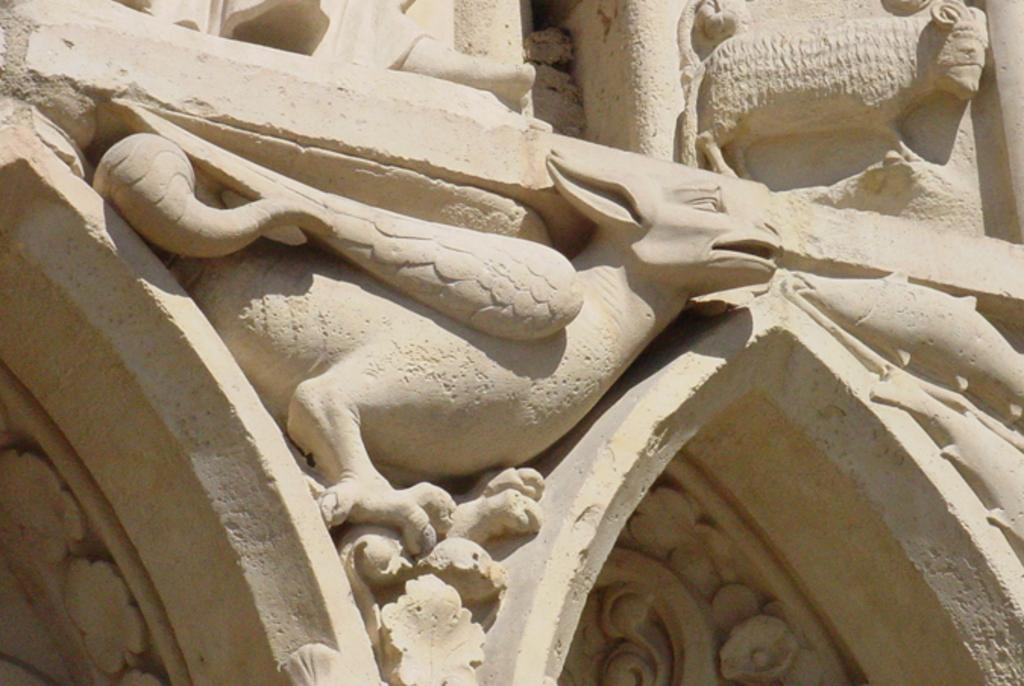What type of artwork can be seen on the wall in the image? There are sculptures on the wall in the image. Can you describe the sculptures in more detail? Unfortunately, the image does not provide enough detail to describe the sculptures further. What might be the purpose of displaying these sculptures on the wall? The purpose of displaying the sculptures could be for decoration, artistic expression, or to convey a message or theme. What type of rhythm can be heard coming from the ghost in the image? There is no ghost present in the image, and therefore no rhythm can be heard. What is the ghost carrying in the crate in the image? There is no ghost or crate present in the image, so it is not possible to answer that question. 